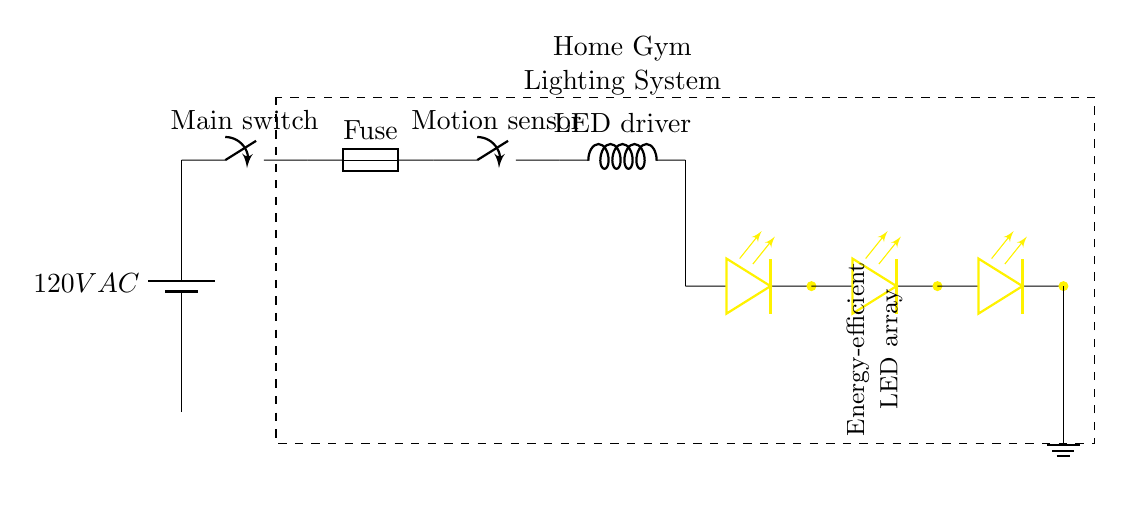What is the main voltage of this circuit? The circuit is powered by a battery labeled as 120V AC, which indicates the voltage supplied to the system.
Answer: 120V AC What is the function of the motion sensor in this circuit? The motion sensor is represented as a closing switch, meaning its role is to turn the circuit on when motion is detected, allowing the LED lights to illuminate only when needed.
Answer: Closing switch How many LED lights are included in the LED array? The LED array shown in the circuit diagram consists of three individual LEDs connected in parallel. This can be seen as three separate LED symbols drawn in succession.
Answer: Three What would happen if the fuse blows in this circuit? If the fuse blows, it will interrupt the current flow in the circuit, preventing any power from reaching the LED driver and thus turning off the LED lights completely.
Answer: Current interruption Identify the component providing power to the LED system. The component providing power is the LED driver, which converts the AC voltage from the battery to the appropriate voltage for the LEDs, ensuring efficient operation.
Answer: LED driver 